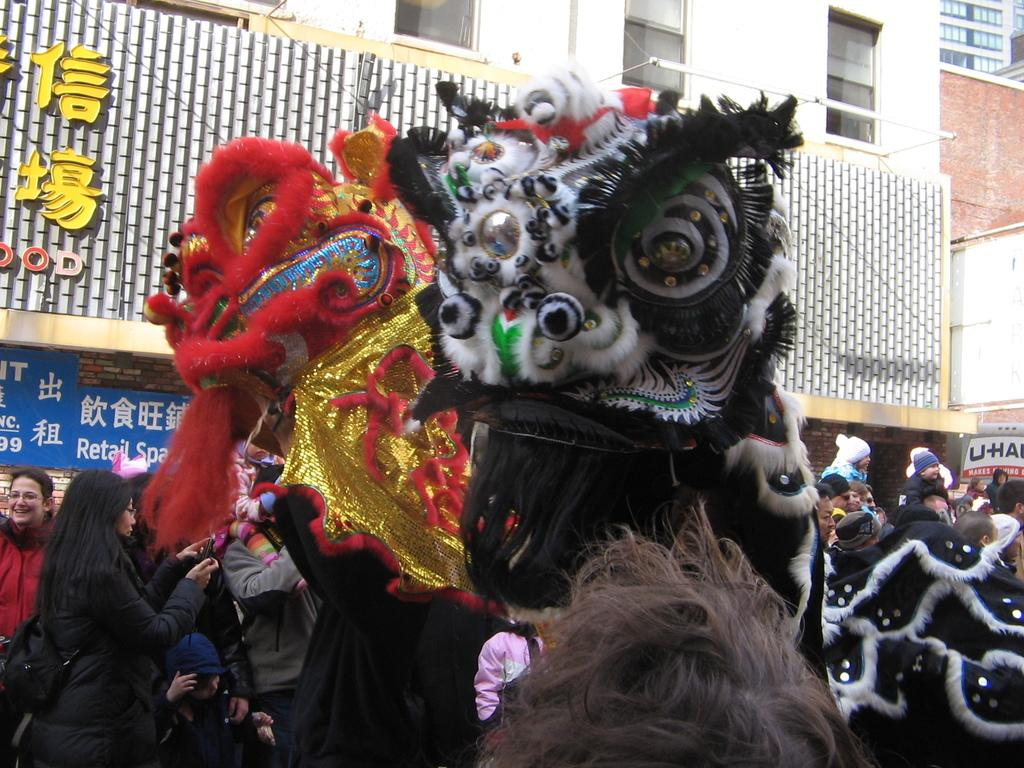Who or what can be seen in the image? There are people and mascots in the image. What is the setting of the image? There are boards and buildings in the background of the image. What type of quartz can be seen in the image? There is no quartz present in the image. How does the son interact with the mascots in the image? There is no mention of a son in the image, so we cannot answer how they might interact with the mascots. 